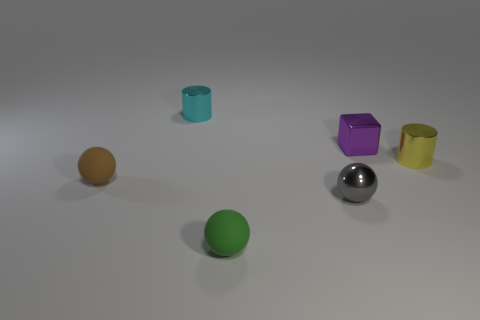Is the color of the cylinder that is to the right of the green thing the same as the small cube?
Your answer should be very brief. No. How many brown objects are the same shape as the tiny purple thing?
Make the answer very short. 0. What number of objects are either small brown spheres left of the tiny gray metal object or small matte things behind the gray ball?
Provide a short and direct response. 1. What number of yellow things are either small metal cylinders or small metal cubes?
Your response must be concise. 1. There is a tiny thing that is to the right of the metallic sphere and on the left side of the yellow shiny cylinder; what is its material?
Your answer should be very brief. Metal. Are the small brown sphere and the tiny cube made of the same material?
Offer a terse response. No. How many objects are the same size as the shiny sphere?
Give a very brief answer. 5. Is the number of small cyan objects in front of the gray ball the same as the number of small matte blocks?
Your answer should be compact. Yes. How many cylinders are both behind the tiny purple metallic thing and on the right side of the small metal sphere?
Your answer should be very brief. 0. There is a small rubber object that is behind the gray thing; does it have the same shape as the small cyan shiny thing?
Your answer should be very brief. No. 